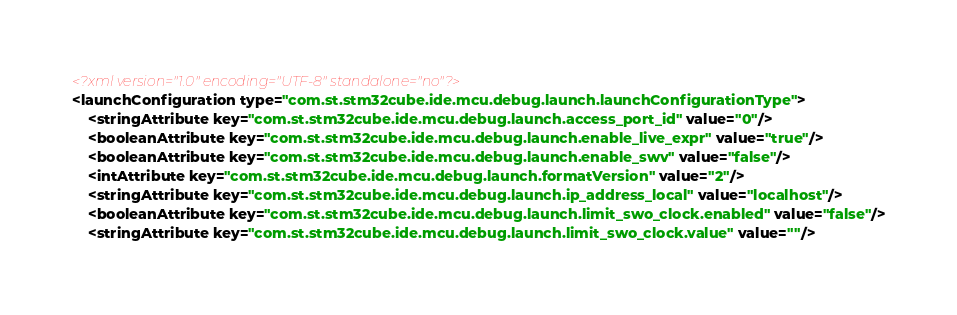<code> <loc_0><loc_0><loc_500><loc_500><_XML_><?xml version="1.0" encoding="UTF-8" standalone="no"?>
<launchConfiguration type="com.st.stm32cube.ide.mcu.debug.launch.launchConfigurationType">
    <stringAttribute key="com.st.stm32cube.ide.mcu.debug.launch.access_port_id" value="0"/>
    <booleanAttribute key="com.st.stm32cube.ide.mcu.debug.launch.enable_live_expr" value="true"/>
    <booleanAttribute key="com.st.stm32cube.ide.mcu.debug.launch.enable_swv" value="false"/>
    <intAttribute key="com.st.stm32cube.ide.mcu.debug.launch.formatVersion" value="2"/>
    <stringAttribute key="com.st.stm32cube.ide.mcu.debug.launch.ip_address_local" value="localhost"/>
    <booleanAttribute key="com.st.stm32cube.ide.mcu.debug.launch.limit_swo_clock.enabled" value="false"/>
    <stringAttribute key="com.st.stm32cube.ide.mcu.debug.launch.limit_swo_clock.value" value=""/></code> 